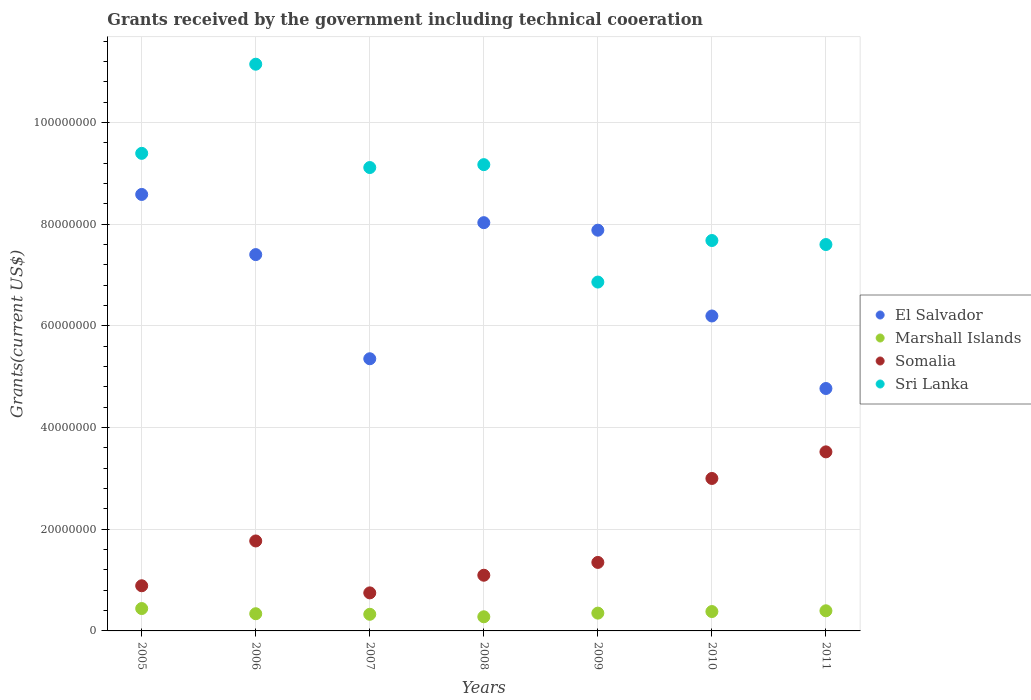How many different coloured dotlines are there?
Your answer should be very brief. 4. What is the total grants received by the government in Marshall Islands in 2006?
Keep it short and to the point. 3.38e+06. Across all years, what is the maximum total grants received by the government in Marshall Islands?
Keep it short and to the point. 4.40e+06. Across all years, what is the minimum total grants received by the government in Somalia?
Offer a terse response. 7.48e+06. In which year was the total grants received by the government in Sri Lanka maximum?
Keep it short and to the point. 2006. What is the total total grants received by the government in Sri Lanka in the graph?
Give a very brief answer. 6.10e+08. What is the difference between the total grants received by the government in Marshall Islands in 2007 and that in 2010?
Provide a short and direct response. -5.40e+05. What is the difference between the total grants received by the government in Somalia in 2011 and the total grants received by the government in El Salvador in 2008?
Ensure brevity in your answer.  -4.51e+07. What is the average total grants received by the government in El Salvador per year?
Offer a very short reply. 6.89e+07. In the year 2006, what is the difference between the total grants received by the government in Somalia and total grants received by the government in Marshall Islands?
Your answer should be compact. 1.43e+07. In how many years, is the total grants received by the government in Marshall Islands greater than 64000000 US$?
Your answer should be very brief. 0. What is the ratio of the total grants received by the government in Sri Lanka in 2005 to that in 2008?
Keep it short and to the point. 1.02. Is the difference between the total grants received by the government in Somalia in 2005 and 2006 greater than the difference between the total grants received by the government in Marshall Islands in 2005 and 2006?
Your response must be concise. No. What is the difference between the highest and the second highest total grants received by the government in Sri Lanka?
Provide a short and direct response. 1.75e+07. What is the difference between the highest and the lowest total grants received by the government in El Salvador?
Offer a terse response. 3.82e+07. In how many years, is the total grants received by the government in El Salvador greater than the average total grants received by the government in El Salvador taken over all years?
Make the answer very short. 4. Is it the case that in every year, the sum of the total grants received by the government in Somalia and total grants received by the government in Marshall Islands  is greater than the sum of total grants received by the government in Sri Lanka and total grants received by the government in El Salvador?
Offer a very short reply. Yes. Is the total grants received by the government in Sri Lanka strictly greater than the total grants received by the government in Somalia over the years?
Offer a very short reply. Yes. Is the total grants received by the government in Sri Lanka strictly less than the total grants received by the government in Marshall Islands over the years?
Make the answer very short. No. How many years are there in the graph?
Give a very brief answer. 7. Does the graph contain any zero values?
Your answer should be compact. No. Does the graph contain grids?
Ensure brevity in your answer.  Yes. How many legend labels are there?
Your answer should be very brief. 4. What is the title of the graph?
Your response must be concise. Grants received by the government including technical cooeration. What is the label or title of the X-axis?
Offer a very short reply. Years. What is the label or title of the Y-axis?
Your answer should be compact. Grants(current US$). What is the Grants(current US$) of El Salvador in 2005?
Make the answer very short. 8.58e+07. What is the Grants(current US$) of Marshall Islands in 2005?
Provide a succinct answer. 4.40e+06. What is the Grants(current US$) in Somalia in 2005?
Offer a terse response. 8.88e+06. What is the Grants(current US$) in Sri Lanka in 2005?
Your answer should be very brief. 9.39e+07. What is the Grants(current US$) of El Salvador in 2006?
Offer a very short reply. 7.40e+07. What is the Grants(current US$) of Marshall Islands in 2006?
Your answer should be compact. 3.38e+06. What is the Grants(current US$) of Somalia in 2006?
Your response must be concise. 1.77e+07. What is the Grants(current US$) of Sri Lanka in 2006?
Provide a short and direct response. 1.11e+08. What is the Grants(current US$) of El Salvador in 2007?
Ensure brevity in your answer.  5.35e+07. What is the Grants(current US$) of Marshall Islands in 2007?
Offer a terse response. 3.27e+06. What is the Grants(current US$) of Somalia in 2007?
Provide a succinct answer. 7.48e+06. What is the Grants(current US$) in Sri Lanka in 2007?
Offer a very short reply. 9.11e+07. What is the Grants(current US$) in El Salvador in 2008?
Keep it short and to the point. 8.03e+07. What is the Grants(current US$) of Marshall Islands in 2008?
Give a very brief answer. 2.78e+06. What is the Grants(current US$) of Somalia in 2008?
Provide a succinct answer. 1.10e+07. What is the Grants(current US$) of Sri Lanka in 2008?
Provide a succinct answer. 9.17e+07. What is the Grants(current US$) of El Salvador in 2009?
Offer a very short reply. 7.88e+07. What is the Grants(current US$) of Marshall Islands in 2009?
Provide a succinct answer. 3.50e+06. What is the Grants(current US$) in Somalia in 2009?
Ensure brevity in your answer.  1.35e+07. What is the Grants(current US$) in Sri Lanka in 2009?
Make the answer very short. 6.86e+07. What is the Grants(current US$) in El Salvador in 2010?
Make the answer very short. 6.19e+07. What is the Grants(current US$) of Marshall Islands in 2010?
Your answer should be very brief. 3.81e+06. What is the Grants(current US$) in Somalia in 2010?
Provide a succinct answer. 3.00e+07. What is the Grants(current US$) of Sri Lanka in 2010?
Offer a very short reply. 7.68e+07. What is the Grants(current US$) of El Salvador in 2011?
Offer a terse response. 4.77e+07. What is the Grants(current US$) of Marshall Islands in 2011?
Give a very brief answer. 3.96e+06. What is the Grants(current US$) in Somalia in 2011?
Your answer should be compact. 3.52e+07. What is the Grants(current US$) in Sri Lanka in 2011?
Make the answer very short. 7.60e+07. Across all years, what is the maximum Grants(current US$) of El Salvador?
Your response must be concise. 8.58e+07. Across all years, what is the maximum Grants(current US$) of Marshall Islands?
Provide a short and direct response. 4.40e+06. Across all years, what is the maximum Grants(current US$) of Somalia?
Give a very brief answer. 3.52e+07. Across all years, what is the maximum Grants(current US$) of Sri Lanka?
Ensure brevity in your answer.  1.11e+08. Across all years, what is the minimum Grants(current US$) in El Salvador?
Keep it short and to the point. 4.77e+07. Across all years, what is the minimum Grants(current US$) of Marshall Islands?
Ensure brevity in your answer.  2.78e+06. Across all years, what is the minimum Grants(current US$) in Somalia?
Your answer should be compact. 7.48e+06. Across all years, what is the minimum Grants(current US$) of Sri Lanka?
Make the answer very short. 6.86e+07. What is the total Grants(current US$) of El Salvador in the graph?
Keep it short and to the point. 4.82e+08. What is the total Grants(current US$) in Marshall Islands in the graph?
Provide a short and direct response. 2.51e+07. What is the total Grants(current US$) of Somalia in the graph?
Keep it short and to the point. 1.24e+08. What is the total Grants(current US$) in Sri Lanka in the graph?
Make the answer very short. 6.10e+08. What is the difference between the Grants(current US$) in El Salvador in 2005 and that in 2006?
Provide a short and direct response. 1.18e+07. What is the difference between the Grants(current US$) in Marshall Islands in 2005 and that in 2006?
Provide a short and direct response. 1.02e+06. What is the difference between the Grants(current US$) in Somalia in 2005 and that in 2006?
Provide a succinct answer. -8.81e+06. What is the difference between the Grants(current US$) in Sri Lanka in 2005 and that in 2006?
Your response must be concise. -1.75e+07. What is the difference between the Grants(current US$) of El Salvador in 2005 and that in 2007?
Provide a succinct answer. 3.23e+07. What is the difference between the Grants(current US$) in Marshall Islands in 2005 and that in 2007?
Your answer should be compact. 1.13e+06. What is the difference between the Grants(current US$) in Somalia in 2005 and that in 2007?
Ensure brevity in your answer.  1.40e+06. What is the difference between the Grants(current US$) in Sri Lanka in 2005 and that in 2007?
Keep it short and to the point. 2.79e+06. What is the difference between the Grants(current US$) of El Salvador in 2005 and that in 2008?
Your answer should be compact. 5.55e+06. What is the difference between the Grants(current US$) of Marshall Islands in 2005 and that in 2008?
Make the answer very short. 1.62e+06. What is the difference between the Grants(current US$) of Somalia in 2005 and that in 2008?
Give a very brief answer. -2.07e+06. What is the difference between the Grants(current US$) in Sri Lanka in 2005 and that in 2008?
Keep it short and to the point. 2.22e+06. What is the difference between the Grants(current US$) in El Salvador in 2005 and that in 2009?
Offer a terse response. 7.03e+06. What is the difference between the Grants(current US$) in Somalia in 2005 and that in 2009?
Ensure brevity in your answer.  -4.59e+06. What is the difference between the Grants(current US$) of Sri Lanka in 2005 and that in 2009?
Your answer should be very brief. 2.53e+07. What is the difference between the Grants(current US$) in El Salvador in 2005 and that in 2010?
Ensure brevity in your answer.  2.39e+07. What is the difference between the Grants(current US$) in Marshall Islands in 2005 and that in 2010?
Offer a terse response. 5.90e+05. What is the difference between the Grants(current US$) of Somalia in 2005 and that in 2010?
Your response must be concise. -2.11e+07. What is the difference between the Grants(current US$) of Sri Lanka in 2005 and that in 2010?
Offer a very short reply. 1.71e+07. What is the difference between the Grants(current US$) in El Salvador in 2005 and that in 2011?
Your answer should be compact. 3.82e+07. What is the difference between the Grants(current US$) of Somalia in 2005 and that in 2011?
Make the answer very short. -2.63e+07. What is the difference between the Grants(current US$) of Sri Lanka in 2005 and that in 2011?
Provide a short and direct response. 1.79e+07. What is the difference between the Grants(current US$) in El Salvador in 2006 and that in 2007?
Make the answer very short. 2.05e+07. What is the difference between the Grants(current US$) of Somalia in 2006 and that in 2007?
Your answer should be very brief. 1.02e+07. What is the difference between the Grants(current US$) in Sri Lanka in 2006 and that in 2007?
Keep it short and to the point. 2.03e+07. What is the difference between the Grants(current US$) in El Salvador in 2006 and that in 2008?
Your response must be concise. -6.28e+06. What is the difference between the Grants(current US$) of Somalia in 2006 and that in 2008?
Ensure brevity in your answer.  6.74e+06. What is the difference between the Grants(current US$) of Sri Lanka in 2006 and that in 2008?
Your answer should be compact. 1.98e+07. What is the difference between the Grants(current US$) of El Salvador in 2006 and that in 2009?
Ensure brevity in your answer.  -4.80e+06. What is the difference between the Grants(current US$) in Somalia in 2006 and that in 2009?
Offer a terse response. 4.22e+06. What is the difference between the Grants(current US$) in Sri Lanka in 2006 and that in 2009?
Provide a short and direct response. 4.28e+07. What is the difference between the Grants(current US$) in El Salvador in 2006 and that in 2010?
Offer a terse response. 1.21e+07. What is the difference between the Grants(current US$) in Marshall Islands in 2006 and that in 2010?
Provide a short and direct response. -4.30e+05. What is the difference between the Grants(current US$) in Somalia in 2006 and that in 2010?
Your response must be concise. -1.23e+07. What is the difference between the Grants(current US$) in Sri Lanka in 2006 and that in 2010?
Ensure brevity in your answer.  3.47e+07. What is the difference between the Grants(current US$) of El Salvador in 2006 and that in 2011?
Your response must be concise. 2.63e+07. What is the difference between the Grants(current US$) in Marshall Islands in 2006 and that in 2011?
Provide a short and direct response. -5.80e+05. What is the difference between the Grants(current US$) in Somalia in 2006 and that in 2011?
Offer a terse response. -1.75e+07. What is the difference between the Grants(current US$) of Sri Lanka in 2006 and that in 2011?
Make the answer very short. 3.55e+07. What is the difference between the Grants(current US$) in El Salvador in 2007 and that in 2008?
Give a very brief answer. -2.68e+07. What is the difference between the Grants(current US$) of Somalia in 2007 and that in 2008?
Make the answer very short. -3.47e+06. What is the difference between the Grants(current US$) in Sri Lanka in 2007 and that in 2008?
Give a very brief answer. -5.70e+05. What is the difference between the Grants(current US$) in El Salvador in 2007 and that in 2009?
Keep it short and to the point. -2.53e+07. What is the difference between the Grants(current US$) in Marshall Islands in 2007 and that in 2009?
Offer a terse response. -2.30e+05. What is the difference between the Grants(current US$) of Somalia in 2007 and that in 2009?
Give a very brief answer. -5.99e+06. What is the difference between the Grants(current US$) in Sri Lanka in 2007 and that in 2009?
Your answer should be very brief. 2.25e+07. What is the difference between the Grants(current US$) of El Salvador in 2007 and that in 2010?
Make the answer very short. -8.41e+06. What is the difference between the Grants(current US$) in Marshall Islands in 2007 and that in 2010?
Keep it short and to the point. -5.40e+05. What is the difference between the Grants(current US$) of Somalia in 2007 and that in 2010?
Give a very brief answer. -2.25e+07. What is the difference between the Grants(current US$) in Sri Lanka in 2007 and that in 2010?
Provide a short and direct response. 1.44e+07. What is the difference between the Grants(current US$) in El Salvador in 2007 and that in 2011?
Ensure brevity in your answer.  5.85e+06. What is the difference between the Grants(current US$) of Marshall Islands in 2007 and that in 2011?
Offer a terse response. -6.90e+05. What is the difference between the Grants(current US$) in Somalia in 2007 and that in 2011?
Offer a very short reply. -2.77e+07. What is the difference between the Grants(current US$) of Sri Lanka in 2007 and that in 2011?
Your response must be concise. 1.51e+07. What is the difference between the Grants(current US$) in El Salvador in 2008 and that in 2009?
Provide a short and direct response. 1.48e+06. What is the difference between the Grants(current US$) in Marshall Islands in 2008 and that in 2009?
Your answer should be very brief. -7.20e+05. What is the difference between the Grants(current US$) of Somalia in 2008 and that in 2009?
Keep it short and to the point. -2.52e+06. What is the difference between the Grants(current US$) in Sri Lanka in 2008 and that in 2009?
Your answer should be compact. 2.31e+07. What is the difference between the Grants(current US$) of El Salvador in 2008 and that in 2010?
Your answer should be very brief. 1.84e+07. What is the difference between the Grants(current US$) of Marshall Islands in 2008 and that in 2010?
Provide a succinct answer. -1.03e+06. What is the difference between the Grants(current US$) in Somalia in 2008 and that in 2010?
Make the answer very short. -1.90e+07. What is the difference between the Grants(current US$) of Sri Lanka in 2008 and that in 2010?
Provide a succinct answer. 1.49e+07. What is the difference between the Grants(current US$) of El Salvador in 2008 and that in 2011?
Make the answer very short. 3.26e+07. What is the difference between the Grants(current US$) of Marshall Islands in 2008 and that in 2011?
Provide a short and direct response. -1.18e+06. What is the difference between the Grants(current US$) of Somalia in 2008 and that in 2011?
Provide a succinct answer. -2.43e+07. What is the difference between the Grants(current US$) of Sri Lanka in 2008 and that in 2011?
Make the answer very short. 1.57e+07. What is the difference between the Grants(current US$) of El Salvador in 2009 and that in 2010?
Ensure brevity in your answer.  1.69e+07. What is the difference between the Grants(current US$) in Marshall Islands in 2009 and that in 2010?
Make the answer very short. -3.10e+05. What is the difference between the Grants(current US$) in Somalia in 2009 and that in 2010?
Your answer should be compact. -1.65e+07. What is the difference between the Grants(current US$) of Sri Lanka in 2009 and that in 2010?
Provide a succinct answer. -8.17e+06. What is the difference between the Grants(current US$) of El Salvador in 2009 and that in 2011?
Your answer should be compact. 3.11e+07. What is the difference between the Grants(current US$) in Marshall Islands in 2009 and that in 2011?
Your response must be concise. -4.60e+05. What is the difference between the Grants(current US$) of Somalia in 2009 and that in 2011?
Provide a succinct answer. -2.17e+07. What is the difference between the Grants(current US$) of Sri Lanka in 2009 and that in 2011?
Offer a very short reply. -7.38e+06. What is the difference between the Grants(current US$) in El Salvador in 2010 and that in 2011?
Keep it short and to the point. 1.43e+07. What is the difference between the Grants(current US$) in Marshall Islands in 2010 and that in 2011?
Keep it short and to the point. -1.50e+05. What is the difference between the Grants(current US$) of Somalia in 2010 and that in 2011?
Ensure brevity in your answer.  -5.23e+06. What is the difference between the Grants(current US$) of Sri Lanka in 2010 and that in 2011?
Keep it short and to the point. 7.90e+05. What is the difference between the Grants(current US$) of El Salvador in 2005 and the Grants(current US$) of Marshall Islands in 2006?
Offer a terse response. 8.24e+07. What is the difference between the Grants(current US$) in El Salvador in 2005 and the Grants(current US$) in Somalia in 2006?
Your answer should be compact. 6.81e+07. What is the difference between the Grants(current US$) in El Salvador in 2005 and the Grants(current US$) in Sri Lanka in 2006?
Give a very brief answer. -2.56e+07. What is the difference between the Grants(current US$) in Marshall Islands in 2005 and the Grants(current US$) in Somalia in 2006?
Your answer should be very brief. -1.33e+07. What is the difference between the Grants(current US$) in Marshall Islands in 2005 and the Grants(current US$) in Sri Lanka in 2006?
Provide a short and direct response. -1.07e+08. What is the difference between the Grants(current US$) of Somalia in 2005 and the Grants(current US$) of Sri Lanka in 2006?
Provide a succinct answer. -1.03e+08. What is the difference between the Grants(current US$) in El Salvador in 2005 and the Grants(current US$) in Marshall Islands in 2007?
Offer a terse response. 8.26e+07. What is the difference between the Grants(current US$) in El Salvador in 2005 and the Grants(current US$) in Somalia in 2007?
Your response must be concise. 7.84e+07. What is the difference between the Grants(current US$) of El Salvador in 2005 and the Grants(current US$) of Sri Lanka in 2007?
Provide a short and direct response. -5.29e+06. What is the difference between the Grants(current US$) in Marshall Islands in 2005 and the Grants(current US$) in Somalia in 2007?
Give a very brief answer. -3.08e+06. What is the difference between the Grants(current US$) of Marshall Islands in 2005 and the Grants(current US$) of Sri Lanka in 2007?
Give a very brief answer. -8.67e+07. What is the difference between the Grants(current US$) in Somalia in 2005 and the Grants(current US$) in Sri Lanka in 2007?
Provide a succinct answer. -8.22e+07. What is the difference between the Grants(current US$) of El Salvador in 2005 and the Grants(current US$) of Marshall Islands in 2008?
Give a very brief answer. 8.30e+07. What is the difference between the Grants(current US$) in El Salvador in 2005 and the Grants(current US$) in Somalia in 2008?
Keep it short and to the point. 7.49e+07. What is the difference between the Grants(current US$) in El Salvador in 2005 and the Grants(current US$) in Sri Lanka in 2008?
Your answer should be compact. -5.86e+06. What is the difference between the Grants(current US$) of Marshall Islands in 2005 and the Grants(current US$) of Somalia in 2008?
Ensure brevity in your answer.  -6.55e+06. What is the difference between the Grants(current US$) in Marshall Islands in 2005 and the Grants(current US$) in Sri Lanka in 2008?
Offer a very short reply. -8.73e+07. What is the difference between the Grants(current US$) in Somalia in 2005 and the Grants(current US$) in Sri Lanka in 2008?
Offer a terse response. -8.28e+07. What is the difference between the Grants(current US$) of El Salvador in 2005 and the Grants(current US$) of Marshall Islands in 2009?
Offer a very short reply. 8.23e+07. What is the difference between the Grants(current US$) in El Salvador in 2005 and the Grants(current US$) in Somalia in 2009?
Provide a succinct answer. 7.24e+07. What is the difference between the Grants(current US$) in El Salvador in 2005 and the Grants(current US$) in Sri Lanka in 2009?
Give a very brief answer. 1.72e+07. What is the difference between the Grants(current US$) of Marshall Islands in 2005 and the Grants(current US$) of Somalia in 2009?
Give a very brief answer. -9.07e+06. What is the difference between the Grants(current US$) in Marshall Islands in 2005 and the Grants(current US$) in Sri Lanka in 2009?
Make the answer very short. -6.42e+07. What is the difference between the Grants(current US$) in Somalia in 2005 and the Grants(current US$) in Sri Lanka in 2009?
Make the answer very short. -5.97e+07. What is the difference between the Grants(current US$) in El Salvador in 2005 and the Grants(current US$) in Marshall Islands in 2010?
Offer a very short reply. 8.20e+07. What is the difference between the Grants(current US$) in El Salvador in 2005 and the Grants(current US$) in Somalia in 2010?
Your answer should be very brief. 5.58e+07. What is the difference between the Grants(current US$) of El Salvador in 2005 and the Grants(current US$) of Sri Lanka in 2010?
Your answer should be compact. 9.06e+06. What is the difference between the Grants(current US$) of Marshall Islands in 2005 and the Grants(current US$) of Somalia in 2010?
Your response must be concise. -2.56e+07. What is the difference between the Grants(current US$) of Marshall Islands in 2005 and the Grants(current US$) of Sri Lanka in 2010?
Your answer should be very brief. -7.24e+07. What is the difference between the Grants(current US$) in Somalia in 2005 and the Grants(current US$) in Sri Lanka in 2010?
Keep it short and to the point. -6.79e+07. What is the difference between the Grants(current US$) in El Salvador in 2005 and the Grants(current US$) in Marshall Islands in 2011?
Provide a succinct answer. 8.19e+07. What is the difference between the Grants(current US$) in El Salvador in 2005 and the Grants(current US$) in Somalia in 2011?
Ensure brevity in your answer.  5.06e+07. What is the difference between the Grants(current US$) in El Salvador in 2005 and the Grants(current US$) in Sri Lanka in 2011?
Ensure brevity in your answer.  9.85e+06. What is the difference between the Grants(current US$) of Marshall Islands in 2005 and the Grants(current US$) of Somalia in 2011?
Offer a terse response. -3.08e+07. What is the difference between the Grants(current US$) of Marshall Islands in 2005 and the Grants(current US$) of Sri Lanka in 2011?
Offer a very short reply. -7.16e+07. What is the difference between the Grants(current US$) of Somalia in 2005 and the Grants(current US$) of Sri Lanka in 2011?
Your answer should be very brief. -6.71e+07. What is the difference between the Grants(current US$) in El Salvador in 2006 and the Grants(current US$) in Marshall Islands in 2007?
Keep it short and to the point. 7.07e+07. What is the difference between the Grants(current US$) of El Salvador in 2006 and the Grants(current US$) of Somalia in 2007?
Your response must be concise. 6.65e+07. What is the difference between the Grants(current US$) in El Salvador in 2006 and the Grants(current US$) in Sri Lanka in 2007?
Keep it short and to the point. -1.71e+07. What is the difference between the Grants(current US$) in Marshall Islands in 2006 and the Grants(current US$) in Somalia in 2007?
Ensure brevity in your answer.  -4.10e+06. What is the difference between the Grants(current US$) of Marshall Islands in 2006 and the Grants(current US$) of Sri Lanka in 2007?
Your answer should be very brief. -8.77e+07. What is the difference between the Grants(current US$) in Somalia in 2006 and the Grants(current US$) in Sri Lanka in 2007?
Offer a very short reply. -7.34e+07. What is the difference between the Grants(current US$) in El Salvador in 2006 and the Grants(current US$) in Marshall Islands in 2008?
Your response must be concise. 7.12e+07. What is the difference between the Grants(current US$) in El Salvador in 2006 and the Grants(current US$) in Somalia in 2008?
Make the answer very short. 6.30e+07. What is the difference between the Grants(current US$) of El Salvador in 2006 and the Grants(current US$) of Sri Lanka in 2008?
Your response must be concise. -1.77e+07. What is the difference between the Grants(current US$) of Marshall Islands in 2006 and the Grants(current US$) of Somalia in 2008?
Provide a succinct answer. -7.57e+06. What is the difference between the Grants(current US$) of Marshall Islands in 2006 and the Grants(current US$) of Sri Lanka in 2008?
Your answer should be compact. -8.83e+07. What is the difference between the Grants(current US$) of Somalia in 2006 and the Grants(current US$) of Sri Lanka in 2008?
Offer a very short reply. -7.40e+07. What is the difference between the Grants(current US$) in El Salvador in 2006 and the Grants(current US$) in Marshall Islands in 2009?
Your answer should be very brief. 7.05e+07. What is the difference between the Grants(current US$) of El Salvador in 2006 and the Grants(current US$) of Somalia in 2009?
Make the answer very short. 6.05e+07. What is the difference between the Grants(current US$) in El Salvador in 2006 and the Grants(current US$) in Sri Lanka in 2009?
Make the answer very short. 5.40e+06. What is the difference between the Grants(current US$) of Marshall Islands in 2006 and the Grants(current US$) of Somalia in 2009?
Your answer should be very brief. -1.01e+07. What is the difference between the Grants(current US$) in Marshall Islands in 2006 and the Grants(current US$) in Sri Lanka in 2009?
Ensure brevity in your answer.  -6.52e+07. What is the difference between the Grants(current US$) in Somalia in 2006 and the Grants(current US$) in Sri Lanka in 2009?
Give a very brief answer. -5.09e+07. What is the difference between the Grants(current US$) in El Salvador in 2006 and the Grants(current US$) in Marshall Islands in 2010?
Offer a very short reply. 7.02e+07. What is the difference between the Grants(current US$) in El Salvador in 2006 and the Grants(current US$) in Somalia in 2010?
Ensure brevity in your answer.  4.40e+07. What is the difference between the Grants(current US$) of El Salvador in 2006 and the Grants(current US$) of Sri Lanka in 2010?
Offer a terse response. -2.77e+06. What is the difference between the Grants(current US$) in Marshall Islands in 2006 and the Grants(current US$) in Somalia in 2010?
Provide a succinct answer. -2.66e+07. What is the difference between the Grants(current US$) of Marshall Islands in 2006 and the Grants(current US$) of Sri Lanka in 2010?
Your response must be concise. -7.34e+07. What is the difference between the Grants(current US$) in Somalia in 2006 and the Grants(current US$) in Sri Lanka in 2010?
Your answer should be very brief. -5.91e+07. What is the difference between the Grants(current US$) of El Salvador in 2006 and the Grants(current US$) of Marshall Islands in 2011?
Your answer should be compact. 7.00e+07. What is the difference between the Grants(current US$) of El Salvador in 2006 and the Grants(current US$) of Somalia in 2011?
Your answer should be compact. 3.88e+07. What is the difference between the Grants(current US$) in El Salvador in 2006 and the Grants(current US$) in Sri Lanka in 2011?
Give a very brief answer. -1.98e+06. What is the difference between the Grants(current US$) in Marshall Islands in 2006 and the Grants(current US$) in Somalia in 2011?
Your answer should be compact. -3.18e+07. What is the difference between the Grants(current US$) of Marshall Islands in 2006 and the Grants(current US$) of Sri Lanka in 2011?
Give a very brief answer. -7.26e+07. What is the difference between the Grants(current US$) of Somalia in 2006 and the Grants(current US$) of Sri Lanka in 2011?
Provide a succinct answer. -5.83e+07. What is the difference between the Grants(current US$) in El Salvador in 2007 and the Grants(current US$) in Marshall Islands in 2008?
Your response must be concise. 5.07e+07. What is the difference between the Grants(current US$) of El Salvador in 2007 and the Grants(current US$) of Somalia in 2008?
Keep it short and to the point. 4.26e+07. What is the difference between the Grants(current US$) of El Salvador in 2007 and the Grants(current US$) of Sri Lanka in 2008?
Offer a very short reply. -3.82e+07. What is the difference between the Grants(current US$) of Marshall Islands in 2007 and the Grants(current US$) of Somalia in 2008?
Keep it short and to the point. -7.68e+06. What is the difference between the Grants(current US$) of Marshall Islands in 2007 and the Grants(current US$) of Sri Lanka in 2008?
Your answer should be very brief. -8.84e+07. What is the difference between the Grants(current US$) of Somalia in 2007 and the Grants(current US$) of Sri Lanka in 2008?
Give a very brief answer. -8.42e+07. What is the difference between the Grants(current US$) of El Salvador in 2007 and the Grants(current US$) of Marshall Islands in 2009?
Give a very brief answer. 5.00e+07. What is the difference between the Grants(current US$) in El Salvador in 2007 and the Grants(current US$) in Somalia in 2009?
Offer a very short reply. 4.00e+07. What is the difference between the Grants(current US$) of El Salvador in 2007 and the Grants(current US$) of Sri Lanka in 2009?
Offer a very short reply. -1.51e+07. What is the difference between the Grants(current US$) in Marshall Islands in 2007 and the Grants(current US$) in Somalia in 2009?
Your answer should be very brief. -1.02e+07. What is the difference between the Grants(current US$) of Marshall Islands in 2007 and the Grants(current US$) of Sri Lanka in 2009?
Keep it short and to the point. -6.53e+07. What is the difference between the Grants(current US$) in Somalia in 2007 and the Grants(current US$) in Sri Lanka in 2009?
Make the answer very short. -6.11e+07. What is the difference between the Grants(current US$) in El Salvador in 2007 and the Grants(current US$) in Marshall Islands in 2010?
Offer a terse response. 4.97e+07. What is the difference between the Grants(current US$) of El Salvador in 2007 and the Grants(current US$) of Somalia in 2010?
Offer a very short reply. 2.35e+07. What is the difference between the Grants(current US$) of El Salvador in 2007 and the Grants(current US$) of Sri Lanka in 2010?
Provide a short and direct response. -2.32e+07. What is the difference between the Grants(current US$) in Marshall Islands in 2007 and the Grants(current US$) in Somalia in 2010?
Keep it short and to the point. -2.67e+07. What is the difference between the Grants(current US$) of Marshall Islands in 2007 and the Grants(current US$) of Sri Lanka in 2010?
Make the answer very short. -7.35e+07. What is the difference between the Grants(current US$) of Somalia in 2007 and the Grants(current US$) of Sri Lanka in 2010?
Offer a very short reply. -6.93e+07. What is the difference between the Grants(current US$) of El Salvador in 2007 and the Grants(current US$) of Marshall Islands in 2011?
Offer a terse response. 4.96e+07. What is the difference between the Grants(current US$) in El Salvador in 2007 and the Grants(current US$) in Somalia in 2011?
Offer a very short reply. 1.83e+07. What is the difference between the Grants(current US$) in El Salvador in 2007 and the Grants(current US$) in Sri Lanka in 2011?
Offer a very short reply. -2.25e+07. What is the difference between the Grants(current US$) of Marshall Islands in 2007 and the Grants(current US$) of Somalia in 2011?
Keep it short and to the point. -3.19e+07. What is the difference between the Grants(current US$) of Marshall Islands in 2007 and the Grants(current US$) of Sri Lanka in 2011?
Give a very brief answer. -7.27e+07. What is the difference between the Grants(current US$) of Somalia in 2007 and the Grants(current US$) of Sri Lanka in 2011?
Keep it short and to the point. -6.85e+07. What is the difference between the Grants(current US$) in El Salvador in 2008 and the Grants(current US$) in Marshall Islands in 2009?
Provide a short and direct response. 7.68e+07. What is the difference between the Grants(current US$) in El Salvador in 2008 and the Grants(current US$) in Somalia in 2009?
Offer a very short reply. 6.68e+07. What is the difference between the Grants(current US$) in El Salvador in 2008 and the Grants(current US$) in Sri Lanka in 2009?
Give a very brief answer. 1.17e+07. What is the difference between the Grants(current US$) in Marshall Islands in 2008 and the Grants(current US$) in Somalia in 2009?
Your answer should be very brief. -1.07e+07. What is the difference between the Grants(current US$) of Marshall Islands in 2008 and the Grants(current US$) of Sri Lanka in 2009?
Your answer should be very brief. -6.58e+07. What is the difference between the Grants(current US$) in Somalia in 2008 and the Grants(current US$) in Sri Lanka in 2009?
Your answer should be compact. -5.76e+07. What is the difference between the Grants(current US$) in El Salvador in 2008 and the Grants(current US$) in Marshall Islands in 2010?
Provide a short and direct response. 7.65e+07. What is the difference between the Grants(current US$) in El Salvador in 2008 and the Grants(current US$) in Somalia in 2010?
Your answer should be compact. 5.03e+07. What is the difference between the Grants(current US$) in El Salvador in 2008 and the Grants(current US$) in Sri Lanka in 2010?
Provide a succinct answer. 3.51e+06. What is the difference between the Grants(current US$) of Marshall Islands in 2008 and the Grants(current US$) of Somalia in 2010?
Offer a terse response. -2.72e+07. What is the difference between the Grants(current US$) of Marshall Islands in 2008 and the Grants(current US$) of Sri Lanka in 2010?
Your answer should be compact. -7.40e+07. What is the difference between the Grants(current US$) in Somalia in 2008 and the Grants(current US$) in Sri Lanka in 2010?
Ensure brevity in your answer.  -6.58e+07. What is the difference between the Grants(current US$) of El Salvador in 2008 and the Grants(current US$) of Marshall Islands in 2011?
Ensure brevity in your answer.  7.63e+07. What is the difference between the Grants(current US$) in El Salvador in 2008 and the Grants(current US$) in Somalia in 2011?
Offer a very short reply. 4.51e+07. What is the difference between the Grants(current US$) in El Salvador in 2008 and the Grants(current US$) in Sri Lanka in 2011?
Give a very brief answer. 4.30e+06. What is the difference between the Grants(current US$) in Marshall Islands in 2008 and the Grants(current US$) in Somalia in 2011?
Offer a very short reply. -3.24e+07. What is the difference between the Grants(current US$) of Marshall Islands in 2008 and the Grants(current US$) of Sri Lanka in 2011?
Offer a terse response. -7.32e+07. What is the difference between the Grants(current US$) in Somalia in 2008 and the Grants(current US$) in Sri Lanka in 2011?
Your answer should be compact. -6.50e+07. What is the difference between the Grants(current US$) of El Salvador in 2009 and the Grants(current US$) of Marshall Islands in 2010?
Make the answer very short. 7.50e+07. What is the difference between the Grants(current US$) of El Salvador in 2009 and the Grants(current US$) of Somalia in 2010?
Give a very brief answer. 4.88e+07. What is the difference between the Grants(current US$) of El Salvador in 2009 and the Grants(current US$) of Sri Lanka in 2010?
Your answer should be compact. 2.03e+06. What is the difference between the Grants(current US$) in Marshall Islands in 2009 and the Grants(current US$) in Somalia in 2010?
Offer a very short reply. -2.65e+07. What is the difference between the Grants(current US$) of Marshall Islands in 2009 and the Grants(current US$) of Sri Lanka in 2010?
Your answer should be very brief. -7.33e+07. What is the difference between the Grants(current US$) of Somalia in 2009 and the Grants(current US$) of Sri Lanka in 2010?
Offer a terse response. -6.33e+07. What is the difference between the Grants(current US$) of El Salvador in 2009 and the Grants(current US$) of Marshall Islands in 2011?
Ensure brevity in your answer.  7.48e+07. What is the difference between the Grants(current US$) of El Salvador in 2009 and the Grants(current US$) of Somalia in 2011?
Give a very brief answer. 4.36e+07. What is the difference between the Grants(current US$) of El Salvador in 2009 and the Grants(current US$) of Sri Lanka in 2011?
Provide a short and direct response. 2.82e+06. What is the difference between the Grants(current US$) of Marshall Islands in 2009 and the Grants(current US$) of Somalia in 2011?
Your answer should be compact. -3.17e+07. What is the difference between the Grants(current US$) in Marshall Islands in 2009 and the Grants(current US$) in Sri Lanka in 2011?
Ensure brevity in your answer.  -7.25e+07. What is the difference between the Grants(current US$) of Somalia in 2009 and the Grants(current US$) of Sri Lanka in 2011?
Give a very brief answer. -6.25e+07. What is the difference between the Grants(current US$) of El Salvador in 2010 and the Grants(current US$) of Marshall Islands in 2011?
Your response must be concise. 5.80e+07. What is the difference between the Grants(current US$) of El Salvador in 2010 and the Grants(current US$) of Somalia in 2011?
Provide a succinct answer. 2.67e+07. What is the difference between the Grants(current US$) of El Salvador in 2010 and the Grants(current US$) of Sri Lanka in 2011?
Provide a short and direct response. -1.40e+07. What is the difference between the Grants(current US$) in Marshall Islands in 2010 and the Grants(current US$) in Somalia in 2011?
Your answer should be very brief. -3.14e+07. What is the difference between the Grants(current US$) of Marshall Islands in 2010 and the Grants(current US$) of Sri Lanka in 2011?
Offer a very short reply. -7.22e+07. What is the difference between the Grants(current US$) of Somalia in 2010 and the Grants(current US$) of Sri Lanka in 2011?
Give a very brief answer. -4.60e+07. What is the average Grants(current US$) in El Salvador per year?
Keep it short and to the point. 6.89e+07. What is the average Grants(current US$) in Marshall Islands per year?
Offer a very short reply. 3.59e+06. What is the average Grants(current US$) in Somalia per year?
Keep it short and to the point. 1.77e+07. What is the average Grants(current US$) of Sri Lanka per year?
Keep it short and to the point. 8.71e+07. In the year 2005, what is the difference between the Grants(current US$) in El Salvador and Grants(current US$) in Marshall Islands?
Provide a succinct answer. 8.14e+07. In the year 2005, what is the difference between the Grants(current US$) in El Salvador and Grants(current US$) in Somalia?
Provide a short and direct response. 7.70e+07. In the year 2005, what is the difference between the Grants(current US$) in El Salvador and Grants(current US$) in Sri Lanka?
Keep it short and to the point. -8.08e+06. In the year 2005, what is the difference between the Grants(current US$) in Marshall Islands and Grants(current US$) in Somalia?
Ensure brevity in your answer.  -4.48e+06. In the year 2005, what is the difference between the Grants(current US$) in Marshall Islands and Grants(current US$) in Sri Lanka?
Offer a terse response. -8.95e+07. In the year 2005, what is the difference between the Grants(current US$) in Somalia and Grants(current US$) in Sri Lanka?
Ensure brevity in your answer.  -8.50e+07. In the year 2006, what is the difference between the Grants(current US$) in El Salvador and Grants(current US$) in Marshall Islands?
Offer a terse response. 7.06e+07. In the year 2006, what is the difference between the Grants(current US$) in El Salvador and Grants(current US$) in Somalia?
Keep it short and to the point. 5.63e+07. In the year 2006, what is the difference between the Grants(current US$) of El Salvador and Grants(current US$) of Sri Lanka?
Ensure brevity in your answer.  -3.74e+07. In the year 2006, what is the difference between the Grants(current US$) in Marshall Islands and Grants(current US$) in Somalia?
Offer a very short reply. -1.43e+07. In the year 2006, what is the difference between the Grants(current US$) of Marshall Islands and Grants(current US$) of Sri Lanka?
Your answer should be compact. -1.08e+08. In the year 2006, what is the difference between the Grants(current US$) in Somalia and Grants(current US$) in Sri Lanka?
Your response must be concise. -9.38e+07. In the year 2007, what is the difference between the Grants(current US$) of El Salvador and Grants(current US$) of Marshall Islands?
Your response must be concise. 5.02e+07. In the year 2007, what is the difference between the Grants(current US$) in El Salvador and Grants(current US$) in Somalia?
Offer a very short reply. 4.60e+07. In the year 2007, what is the difference between the Grants(current US$) of El Salvador and Grants(current US$) of Sri Lanka?
Offer a terse response. -3.76e+07. In the year 2007, what is the difference between the Grants(current US$) in Marshall Islands and Grants(current US$) in Somalia?
Provide a short and direct response. -4.21e+06. In the year 2007, what is the difference between the Grants(current US$) of Marshall Islands and Grants(current US$) of Sri Lanka?
Provide a succinct answer. -8.78e+07. In the year 2007, what is the difference between the Grants(current US$) in Somalia and Grants(current US$) in Sri Lanka?
Offer a very short reply. -8.36e+07. In the year 2008, what is the difference between the Grants(current US$) of El Salvador and Grants(current US$) of Marshall Islands?
Ensure brevity in your answer.  7.75e+07. In the year 2008, what is the difference between the Grants(current US$) of El Salvador and Grants(current US$) of Somalia?
Your answer should be compact. 6.93e+07. In the year 2008, what is the difference between the Grants(current US$) of El Salvador and Grants(current US$) of Sri Lanka?
Your answer should be very brief. -1.14e+07. In the year 2008, what is the difference between the Grants(current US$) in Marshall Islands and Grants(current US$) in Somalia?
Make the answer very short. -8.17e+06. In the year 2008, what is the difference between the Grants(current US$) in Marshall Islands and Grants(current US$) in Sri Lanka?
Ensure brevity in your answer.  -8.89e+07. In the year 2008, what is the difference between the Grants(current US$) of Somalia and Grants(current US$) of Sri Lanka?
Make the answer very short. -8.07e+07. In the year 2009, what is the difference between the Grants(current US$) in El Salvador and Grants(current US$) in Marshall Islands?
Make the answer very short. 7.53e+07. In the year 2009, what is the difference between the Grants(current US$) in El Salvador and Grants(current US$) in Somalia?
Provide a short and direct response. 6.53e+07. In the year 2009, what is the difference between the Grants(current US$) in El Salvador and Grants(current US$) in Sri Lanka?
Give a very brief answer. 1.02e+07. In the year 2009, what is the difference between the Grants(current US$) in Marshall Islands and Grants(current US$) in Somalia?
Offer a terse response. -9.97e+06. In the year 2009, what is the difference between the Grants(current US$) of Marshall Islands and Grants(current US$) of Sri Lanka?
Provide a short and direct response. -6.51e+07. In the year 2009, what is the difference between the Grants(current US$) in Somalia and Grants(current US$) in Sri Lanka?
Your answer should be compact. -5.51e+07. In the year 2010, what is the difference between the Grants(current US$) in El Salvador and Grants(current US$) in Marshall Islands?
Ensure brevity in your answer.  5.81e+07. In the year 2010, what is the difference between the Grants(current US$) in El Salvador and Grants(current US$) in Somalia?
Offer a terse response. 3.20e+07. In the year 2010, what is the difference between the Grants(current US$) in El Salvador and Grants(current US$) in Sri Lanka?
Ensure brevity in your answer.  -1.48e+07. In the year 2010, what is the difference between the Grants(current US$) of Marshall Islands and Grants(current US$) of Somalia?
Keep it short and to the point. -2.62e+07. In the year 2010, what is the difference between the Grants(current US$) in Marshall Islands and Grants(current US$) in Sri Lanka?
Your answer should be compact. -7.30e+07. In the year 2010, what is the difference between the Grants(current US$) of Somalia and Grants(current US$) of Sri Lanka?
Your response must be concise. -4.68e+07. In the year 2011, what is the difference between the Grants(current US$) of El Salvador and Grants(current US$) of Marshall Islands?
Your response must be concise. 4.37e+07. In the year 2011, what is the difference between the Grants(current US$) of El Salvador and Grants(current US$) of Somalia?
Your answer should be very brief. 1.25e+07. In the year 2011, what is the difference between the Grants(current US$) of El Salvador and Grants(current US$) of Sri Lanka?
Keep it short and to the point. -2.83e+07. In the year 2011, what is the difference between the Grants(current US$) of Marshall Islands and Grants(current US$) of Somalia?
Give a very brief answer. -3.12e+07. In the year 2011, what is the difference between the Grants(current US$) in Marshall Islands and Grants(current US$) in Sri Lanka?
Provide a short and direct response. -7.20e+07. In the year 2011, what is the difference between the Grants(current US$) of Somalia and Grants(current US$) of Sri Lanka?
Provide a short and direct response. -4.08e+07. What is the ratio of the Grants(current US$) of El Salvador in 2005 to that in 2006?
Offer a very short reply. 1.16. What is the ratio of the Grants(current US$) of Marshall Islands in 2005 to that in 2006?
Ensure brevity in your answer.  1.3. What is the ratio of the Grants(current US$) of Somalia in 2005 to that in 2006?
Your answer should be very brief. 0.5. What is the ratio of the Grants(current US$) of Sri Lanka in 2005 to that in 2006?
Your response must be concise. 0.84. What is the ratio of the Grants(current US$) in El Salvador in 2005 to that in 2007?
Give a very brief answer. 1.6. What is the ratio of the Grants(current US$) in Marshall Islands in 2005 to that in 2007?
Offer a very short reply. 1.35. What is the ratio of the Grants(current US$) of Somalia in 2005 to that in 2007?
Ensure brevity in your answer.  1.19. What is the ratio of the Grants(current US$) of Sri Lanka in 2005 to that in 2007?
Your answer should be compact. 1.03. What is the ratio of the Grants(current US$) in El Salvador in 2005 to that in 2008?
Your response must be concise. 1.07. What is the ratio of the Grants(current US$) in Marshall Islands in 2005 to that in 2008?
Your answer should be very brief. 1.58. What is the ratio of the Grants(current US$) of Somalia in 2005 to that in 2008?
Make the answer very short. 0.81. What is the ratio of the Grants(current US$) in Sri Lanka in 2005 to that in 2008?
Keep it short and to the point. 1.02. What is the ratio of the Grants(current US$) of El Salvador in 2005 to that in 2009?
Your answer should be very brief. 1.09. What is the ratio of the Grants(current US$) in Marshall Islands in 2005 to that in 2009?
Your response must be concise. 1.26. What is the ratio of the Grants(current US$) of Somalia in 2005 to that in 2009?
Your response must be concise. 0.66. What is the ratio of the Grants(current US$) of Sri Lanka in 2005 to that in 2009?
Give a very brief answer. 1.37. What is the ratio of the Grants(current US$) in El Salvador in 2005 to that in 2010?
Offer a terse response. 1.39. What is the ratio of the Grants(current US$) in Marshall Islands in 2005 to that in 2010?
Offer a very short reply. 1.15. What is the ratio of the Grants(current US$) in Somalia in 2005 to that in 2010?
Provide a short and direct response. 0.3. What is the ratio of the Grants(current US$) in Sri Lanka in 2005 to that in 2010?
Your answer should be very brief. 1.22. What is the ratio of the Grants(current US$) of El Salvador in 2005 to that in 2011?
Ensure brevity in your answer.  1.8. What is the ratio of the Grants(current US$) in Somalia in 2005 to that in 2011?
Your response must be concise. 0.25. What is the ratio of the Grants(current US$) of Sri Lanka in 2005 to that in 2011?
Your answer should be compact. 1.24. What is the ratio of the Grants(current US$) of El Salvador in 2006 to that in 2007?
Your answer should be compact. 1.38. What is the ratio of the Grants(current US$) of Marshall Islands in 2006 to that in 2007?
Your answer should be very brief. 1.03. What is the ratio of the Grants(current US$) of Somalia in 2006 to that in 2007?
Your response must be concise. 2.37. What is the ratio of the Grants(current US$) of Sri Lanka in 2006 to that in 2007?
Provide a short and direct response. 1.22. What is the ratio of the Grants(current US$) in El Salvador in 2006 to that in 2008?
Your response must be concise. 0.92. What is the ratio of the Grants(current US$) of Marshall Islands in 2006 to that in 2008?
Keep it short and to the point. 1.22. What is the ratio of the Grants(current US$) of Somalia in 2006 to that in 2008?
Your answer should be very brief. 1.62. What is the ratio of the Grants(current US$) in Sri Lanka in 2006 to that in 2008?
Your response must be concise. 1.22. What is the ratio of the Grants(current US$) in El Salvador in 2006 to that in 2009?
Offer a very short reply. 0.94. What is the ratio of the Grants(current US$) of Marshall Islands in 2006 to that in 2009?
Make the answer very short. 0.97. What is the ratio of the Grants(current US$) of Somalia in 2006 to that in 2009?
Your answer should be very brief. 1.31. What is the ratio of the Grants(current US$) of Sri Lanka in 2006 to that in 2009?
Your answer should be very brief. 1.62. What is the ratio of the Grants(current US$) in El Salvador in 2006 to that in 2010?
Offer a terse response. 1.19. What is the ratio of the Grants(current US$) in Marshall Islands in 2006 to that in 2010?
Your answer should be compact. 0.89. What is the ratio of the Grants(current US$) in Somalia in 2006 to that in 2010?
Provide a short and direct response. 0.59. What is the ratio of the Grants(current US$) of Sri Lanka in 2006 to that in 2010?
Give a very brief answer. 1.45. What is the ratio of the Grants(current US$) of El Salvador in 2006 to that in 2011?
Your answer should be compact. 1.55. What is the ratio of the Grants(current US$) of Marshall Islands in 2006 to that in 2011?
Offer a very short reply. 0.85. What is the ratio of the Grants(current US$) in Somalia in 2006 to that in 2011?
Offer a very short reply. 0.5. What is the ratio of the Grants(current US$) in Sri Lanka in 2006 to that in 2011?
Keep it short and to the point. 1.47. What is the ratio of the Grants(current US$) in El Salvador in 2007 to that in 2008?
Keep it short and to the point. 0.67. What is the ratio of the Grants(current US$) of Marshall Islands in 2007 to that in 2008?
Your answer should be very brief. 1.18. What is the ratio of the Grants(current US$) in Somalia in 2007 to that in 2008?
Keep it short and to the point. 0.68. What is the ratio of the Grants(current US$) of Sri Lanka in 2007 to that in 2008?
Make the answer very short. 0.99. What is the ratio of the Grants(current US$) in El Salvador in 2007 to that in 2009?
Your answer should be very brief. 0.68. What is the ratio of the Grants(current US$) in Marshall Islands in 2007 to that in 2009?
Provide a short and direct response. 0.93. What is the ratio of the Grants(current US$) in Somalia in 2007 to that in 2009?
Ensure brevity in your answer.  0.56. What is the ratio of the Grants(current US$) in Sri Lanka in 2007 to that in 2009?
Ensure brevity in your answer.  1.33. What is the ratio of the Grants(current US$) of El Salvador in 2007 to that in 2010?
Keep it short and to the point. 0.86. What is the ratio of the Grants(current US$) in Marshall Islands in 2007 to that in 2010?
Keep it short and to the point. 0.86. What is the ratio of the Grants(current US$) in Somalia in 2007 to that in 2010?
Give a very brief answer. 0.25. What is the ratio of the Grants(current US$) in Sri Lanka in 2007 to that in 2010?
Your answer should be compact. 1.19. What is the ratio of the Grants(current US$) in El Salvador in 2007 to that in 2011?
Keep it short and to the point. 1.12. What is the ratio of the Grants(current US$) of Marshall Islands in 2007 to that in 2011?
Your answer should be compact. 0.83. What is the ratio of the Grants(current US$) in Somalia in 2007 to that in 2011?
Your response must be concise. 0.21. What is the ratio of the Grants(current US$) of Sri Lanka in 2007 to that in 2011?
Your answer should be very brief. 1.2. What is the ratio of the Grants(current US$) of El Salvador in 2008 to that in 2009?
Provide a succinct answer. 1.02. What is the ratio of the Grants(current US$) of Marshall Islands in 2008 to that in 2009?
Give a very brief answer. 0.79. What is the ratio of the Grants(current US$) of Somalia in 2008 to that in 2009?
Offer a terse response. 0.81. What is the ratio of the Grants(current US$) of Sri Lanka in 2008 to that in 2009?
Keep it short and to the point. 1.34. What is the ratio of the Grants(current US$) of El Salvador in 2008 to that in 2010?
Provide a short and direct response. 1.3. What is the ratio of the Grants(current US$) of Marshall Islands in 2008 to that in 2010?
Ensure brevity in your answer.  0.73. What is the ratio of the Grants(current US$) of Somalia in 2008 to that in 2010?
Keep it short and to the point. 0.37. What is the ratio of the Grants(current US$) in Sri Lanka in 2008 to that in 2010?
Keep it short and to the point. 1.19. What is the ratio of the Grants(current US$) of El Salvador in 2008 to that in 2011?
Give a very brief answer. 1.68. What is the ratio of the Grants(current US$) in Marshall Islands in 2008 to that in 2011?
Make the answer very short. 0.7. What is the ratio of the Grants(current US$) in Somalia in 2008 to that in 2011?
Keep it short and to the point. 0.31. What is the ratio of the Grants(current US$) in Sri Lanka in 2008 to that in 2011?
Give a very brief answer. 1.21. What is the ratio of the Grants(current US$) of El Salvador in 2009 to that in 2010?
Offer a terse response. 1.27. What is the ratio of the Grants(current US$) in Marshall Islands in 2009 to that in 2010?
Make the answer very short. 0.92. What is the ratio of the Grants(current US$) in Somalia in 2009 to that in 2010?
Provide a short and direct response. 0.45. What is the ratio of the Grants(current US$) of Sri Lanka in 2009 to that in 2010?
Make the answer very short. 0.89. What is the ratio of the Grants(current US$) of El Salvador in 2009 to that in 2011?
Ensure brevity in your answer.  1.65. What is the ratio of the Grants(current US$) of Marshall Islands in 2009 to that in 2011?
Ensure brevity in your answer.  0.88. What is the ratio of the Grants(current US$) in Somalia in 2009 to that in 2011?
Keep it short and to the point. 0.38. What is the ratio of the Grants(current US$) in Sri Lanka in 2009 to that in 2011?
Keep it short and to the point. 0.9. What is the ratio of the Grants(current US$) of El Salvador in 2010 to that in 2011?
Offer a very short reply. 1.3. What is the ratio of the Grants(current US$) in Marshall Islands in 2010 to that in 2011?
Keep it short and to the point. 0.96. What is the ratio of the Grants(current US$) in Somalia in 2010 to that in 2011?
Provide a short and direct response. 0.85. What is the ratio of the Grants(current US$) in Sri Lanka in 2010 to that in 2011?
Your answer should be compact. 1.01. What is the difference between the highest and the second highest Grants(current US$) of El Salvador?
Provide a short and direct response. 5.55e+06. What is the difference between the highest and the second highest Grants(current US$) in Somalia?
Your answer should be very brief. 5.23e+06. What is the difference between the highest and the second highest Grants(current US$) of Sri Lanka?
Ensure brevity in your answer.  1.75e+07. What is the difference between the highest and the lowest Grants(current US$) in El Salvador?
Give a very brief answer. 3.82e+07. What is the difference between the highest and the lowest Grants(current US$) in Marshall Islands?
Keep it short and to the point. 1.62e+06. What is the difference between the highest and the lowest Grants(current US$) in Somalia?
Your answer should be compact. 2.77e+07. What is the difference between the highest and the lowest Grants(current US$) in Sri Lanka?
Make the answer very short. 4.28e+07. 